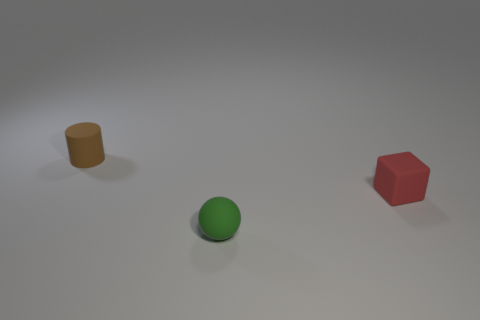There is a small object that is to the left of the green thing; how many green rubber spheres are right of it?
Offer a very short reply. 1. Is the number of small brown matte objects greater than the number of red rubber cylinders?
Offer a terse response. Yes. Are the cylinder and the small red thing made of the same material?
Provide a succinct answer. Yes. Is the number of tiny blocks behind the small green object the same as the number of small cyan matte spheres?
Your response must be concise. No. What number of small red things have the same material as the small brown object?
Ensure brevity in your answer.  1. Is the number of brown matte cylinders less than the number of large purple metal blocks?
Your response must be concise. No. How many red rubber cubes are in front of the tiny rubber object that is behind the small rubber object that is on the right side of the small green matte object?
Offer a very short reply. 1. What number of red matte blocks are behind the small green matte ball?
Offer a terse response. 1. There is a thing that is to the left of the ball; does it have the same size as the red matte block?
Give a very brief answer. Yes. The tiny rubber thing in front of the matte block is what color?
Provide a succinct answer. Green. 